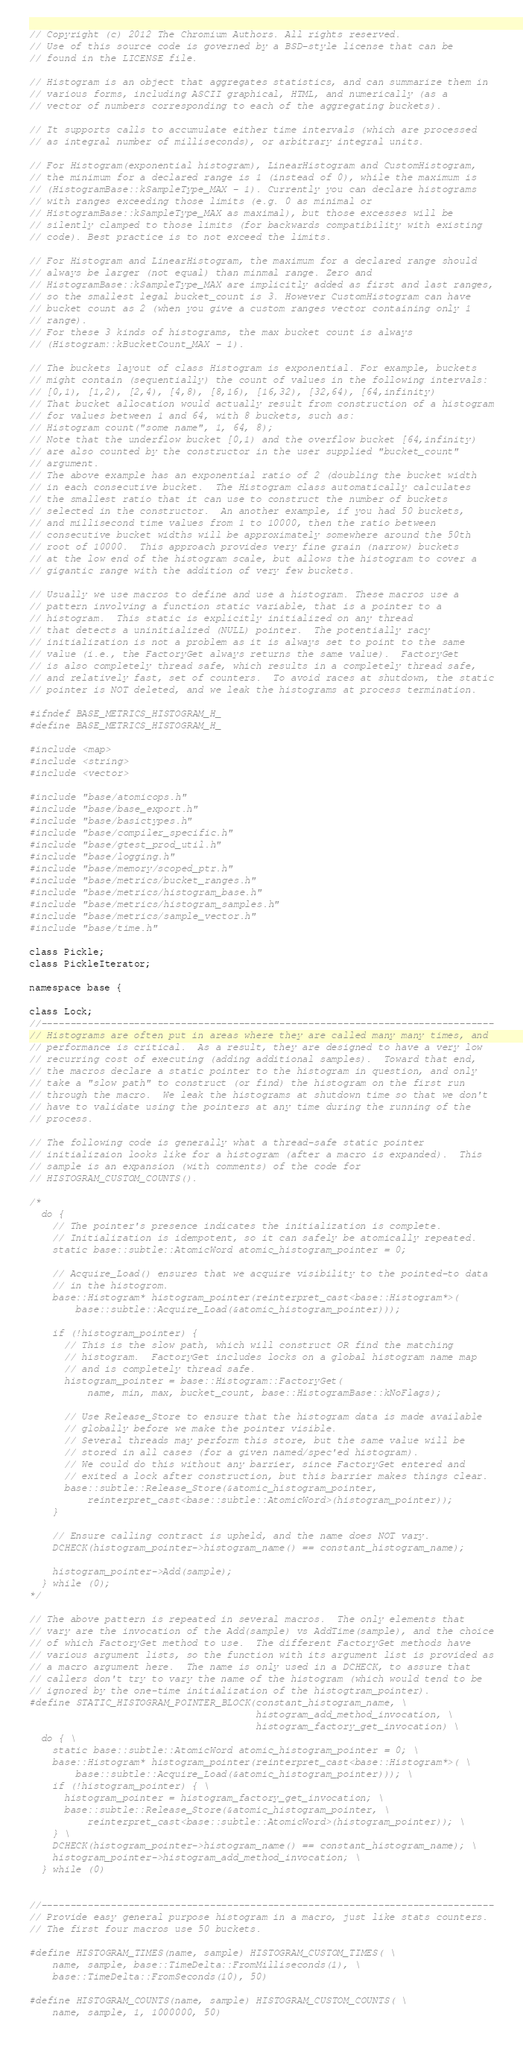<code> <loc_0><loc_0><loc_500><loc_500><_C_>// Copyright (c) 2012 The Chromium Authors. All rights reserved.
// Use of this source code is governed by a BSD-style license that can be
// found in the LICENSE file.

// Histogram is an object that aggregates statistics, and can summarize them in
// various forms, including ASCII graphical, HTML, and numerically (as a
// vector of numbers corresponding to each of the aggregating buckets).

// It supports calls to accumulate either time intervals (which are processed
// as integral number of milliseconds), or arbitrary integral units.

// For Histogram(exponential histogram), LinearHistogram and CustomHistogram,
// the minimum for a declared range is 1 (instead of 0), while the maximum is
// (HistogramBase::kSampleType_MAX - 1). Currently you can declare histograms
// with ranges exceeding those limits (e.g. 0 as minimal or
// HistogramBase::kSampleType_MAX as maximal), but those excesses will be
// silently clamped to those limits (for backwards compatibility with existing
// code). Best practice is to not exceed the limits.

// For Histogram and LinearHistogram, the maximum for a declared range should
// always be larger (not equal) than minmal range. Zero and
// HistogramBase::kSampleType_MAX are implicitly added as first and last ranges,
// so the smallest legal bucket_count is 3. However CustomHistogram can have
// bucket count as 2 (when you give a custom ranges vector containing only 1
// range).
// For these 3 kinds of histograms, the max bucket count is always
// (Histogram::kBucketCount_MAX - 1).

// The buckets layout of class Histogram is exponential. For example, buckets
// might contain (sequentially) the count of values in the following intervals:
// [0,1), [1,2), [2,4), [4,8), [8,16), [16,32), [32,64), [64,infinity)
// That bucket allocation would actually result from construction of a histogram
// for values between 1 and 64, with 8 buckets, such as:
// Histogram count("some name", 1, 64, 8);
// Note that the underflow bucket [0,1) and the overflow bucket [64,infinity)
// are also counted by the constructor in the user supplied "bucket_count"
// argument.
// The above example has an exponential ratio of 2 (doubling the bucket width
// in each consecutive bucket.  The Histogram class automatically calculates
// the smallest ratio that it can use to construct the number of buckets
// selected in the constructor.  An another example, if you had 50 buckets,
// and millisecond time values from 1 to 10000, then the ratio between
// consecutive bucket widths will be approximately somewhere around the 50th
// root of 10000.  This approach provides very fine grain (narrow) buckets
// at the low end of the histogram scale, but allows the histogram to cover a
// gigantic range with the addition of very few buckets.

// Usually we use macros to define and use a histogram. These macros use a
// pattern involving a function static variable, that is a pointer to a
// histogram.  This static is explicitly initialized on any thread
// that detects a uninitialized (NULL) pointer.  The potentially racy
// initialization is not a problem as it is always set to point to the same
// value (i.e., the FactoryGet always returns the same value).  FactoryGet
// is also completely thread safe, which results in a completely thread safe,
// and relatively fast, set of counters.  To avoid races at shutdown, the static
// pointer is NOT deleted, and we leak the histograms at process termination.

#ifndef BASE_METRICS_HISTOGRAM_H_
#define BASE_METRICS_HISTOGRAM_H_

#include <map>
#include <string>
#include <vector>

#include "base/atomicops.h"
#include "base/base_export.h"
#include "base/basictypes.h"
#include "base/compiler_specific.h"
#include "base/gtest_prod_util.h"
#include "base/logging.h"
#include "base/memory/scoped_ptr.h"
#include "base/metrics/bucket_ranges.h"
#include "base/metrics/histogram_base.h"
#include "base/metrics/histogram_samples.h"
#include "base/metrics/sample_vector.h"
#include "base/time.h"

class Pickle;
class PickleIterator;

namespace base {

class Lock;
//------------------------------------------------------------------------------
// Histograms are often put in areas where they are called many many times, and
// performance is critical.  As a result, they are designed to have a very low
// recurring cost of executing (adding additional samples).  Toward that end,
// the macros declare a static pointer to the histogram in question, and only
// take a "slow path" to construct (or find) the histogram on the first run
// through the macro.  We leak the histograms at shutdown time so that we don't
// have to validate using the pointers at any time during the running of the
// process.

// The following code is generally what a thread-safe static pointer
// initializaion looks like for a histogram (after a macro is expanded).  This
// sample is an expansion (with comments) of the code for
// HISTOGRAM_CUSTOM_COUNTS().

/*
  do {
    // The pointer's presence indicates the initialization is complete.
    // Initialization is idempotent, so it can safely be atomically repeated.
    static base::subtle::AtomicWord atomic_histogram_pointer = 0;

    // Acquire_Load() ensures that we acquire visibility to the pointed-to data
    // in the histogrom.
    base::Histogram* histogram_pointer(reinterpret_cast<base::Histogram*>(
        base::subtle::Acquire_Load(&atomic_histogram_pointer)));

    if (!histogram_pointer) {
      // This is the slow path, which will construct OR find the matching
      // histogram.  FactoryGet includes locks on a global histogram name map
      // and is completely thread safe.
      histogram_pointer = base::Histogram::FactoryGet(
          name, min, max, bucket_count, base::HistogramBase::kNoFlags);

      // Use Release_Store to ensure that the histogram data is made available
      // globally before we make the pointer visible.
      // Several threads may perform this store, but the same value will be
      // stored in all cases (for a given named/spec'ed histogram).
      // We could do this without any barrier, since FactoryGet entered and
      // exited a lock after construction, but this barrier makes things clear.
      base::subtle::Release_Store(&atomic_histogram_pointer,
          reinterpret_cast<base::subtle::AtomicWord>(histogram_pointer));
    }

    // Ensure calling contract is upheld, and the name does NOT vary.
    DCHECK(histogram_pointer->histogram_name() == constant_histogram_name);

    histogram_pointer->Add(sample);
  } while (0);
*/

// The above pattern is repeated in several macros.  The only elements that
// vary are the invocation of the Add(sample) vs AddTime(sample), and the choice
// of which FactoryGet method to use.  The different FactoryGet methods have
// various argument lists, so the function with its argument list is provided as
// a macro argument here.  The name is only used in a DCHECK, to assure that
// callers don't try to vary the name of the histogram (which would tend to be
// ignored by the one-time initialization of the histogtram_pointer).
#define STATIC_HISTOGRAM_POINTER_BLOCK(constant_histogram_name, \
                                       histogram_add_method_invocation, \
                                       histogram_factory_get_invocation) \
  do { \
    static base::subtle::AtomicWord atomic_histogram_pointer = 0; \
    base::Histogram* histogram_pointer(reinterpret_cast<base::Histogram*>( \
        base::subtle::Acquire_Load(&atomic_histogram_pointer))); \
    if (!histogram_pointer) { \
      histogram_pointer = histogram_factory_get_invocation; \
      base::subtle::Release_Store(&atomic_histogram_pointer, \
          reinterpret_cast<base::subtle::AtomicWord>(histogram_pointer)); \
    } \
    DCHECK(histogram_pointer->histogram_name() == constant_histogram_name); \
    histogram_pointer->histogram_add_method_invocation; \
  } while (0)


//------------------------------------------------------------------------------
// Provide easy general purpose histogram in a macro, just like stats counters.
// The first four macros use 50 buckets.

#define HISTOGRAM_TIMES(name, sample) HISTOGRAM_CUSTOM_TIMES( \
    name, sample, base::TimeDelta::FromMilliseconds(1), \
    base::TimeDelta::FromSeconds(10), 50)

#define HISTOGRAM_COUNTS(name, sample) HISTOGRAM_CUSTOM_COUNTS( \
    name, sample, 1, 1000000, 50)
</code> 